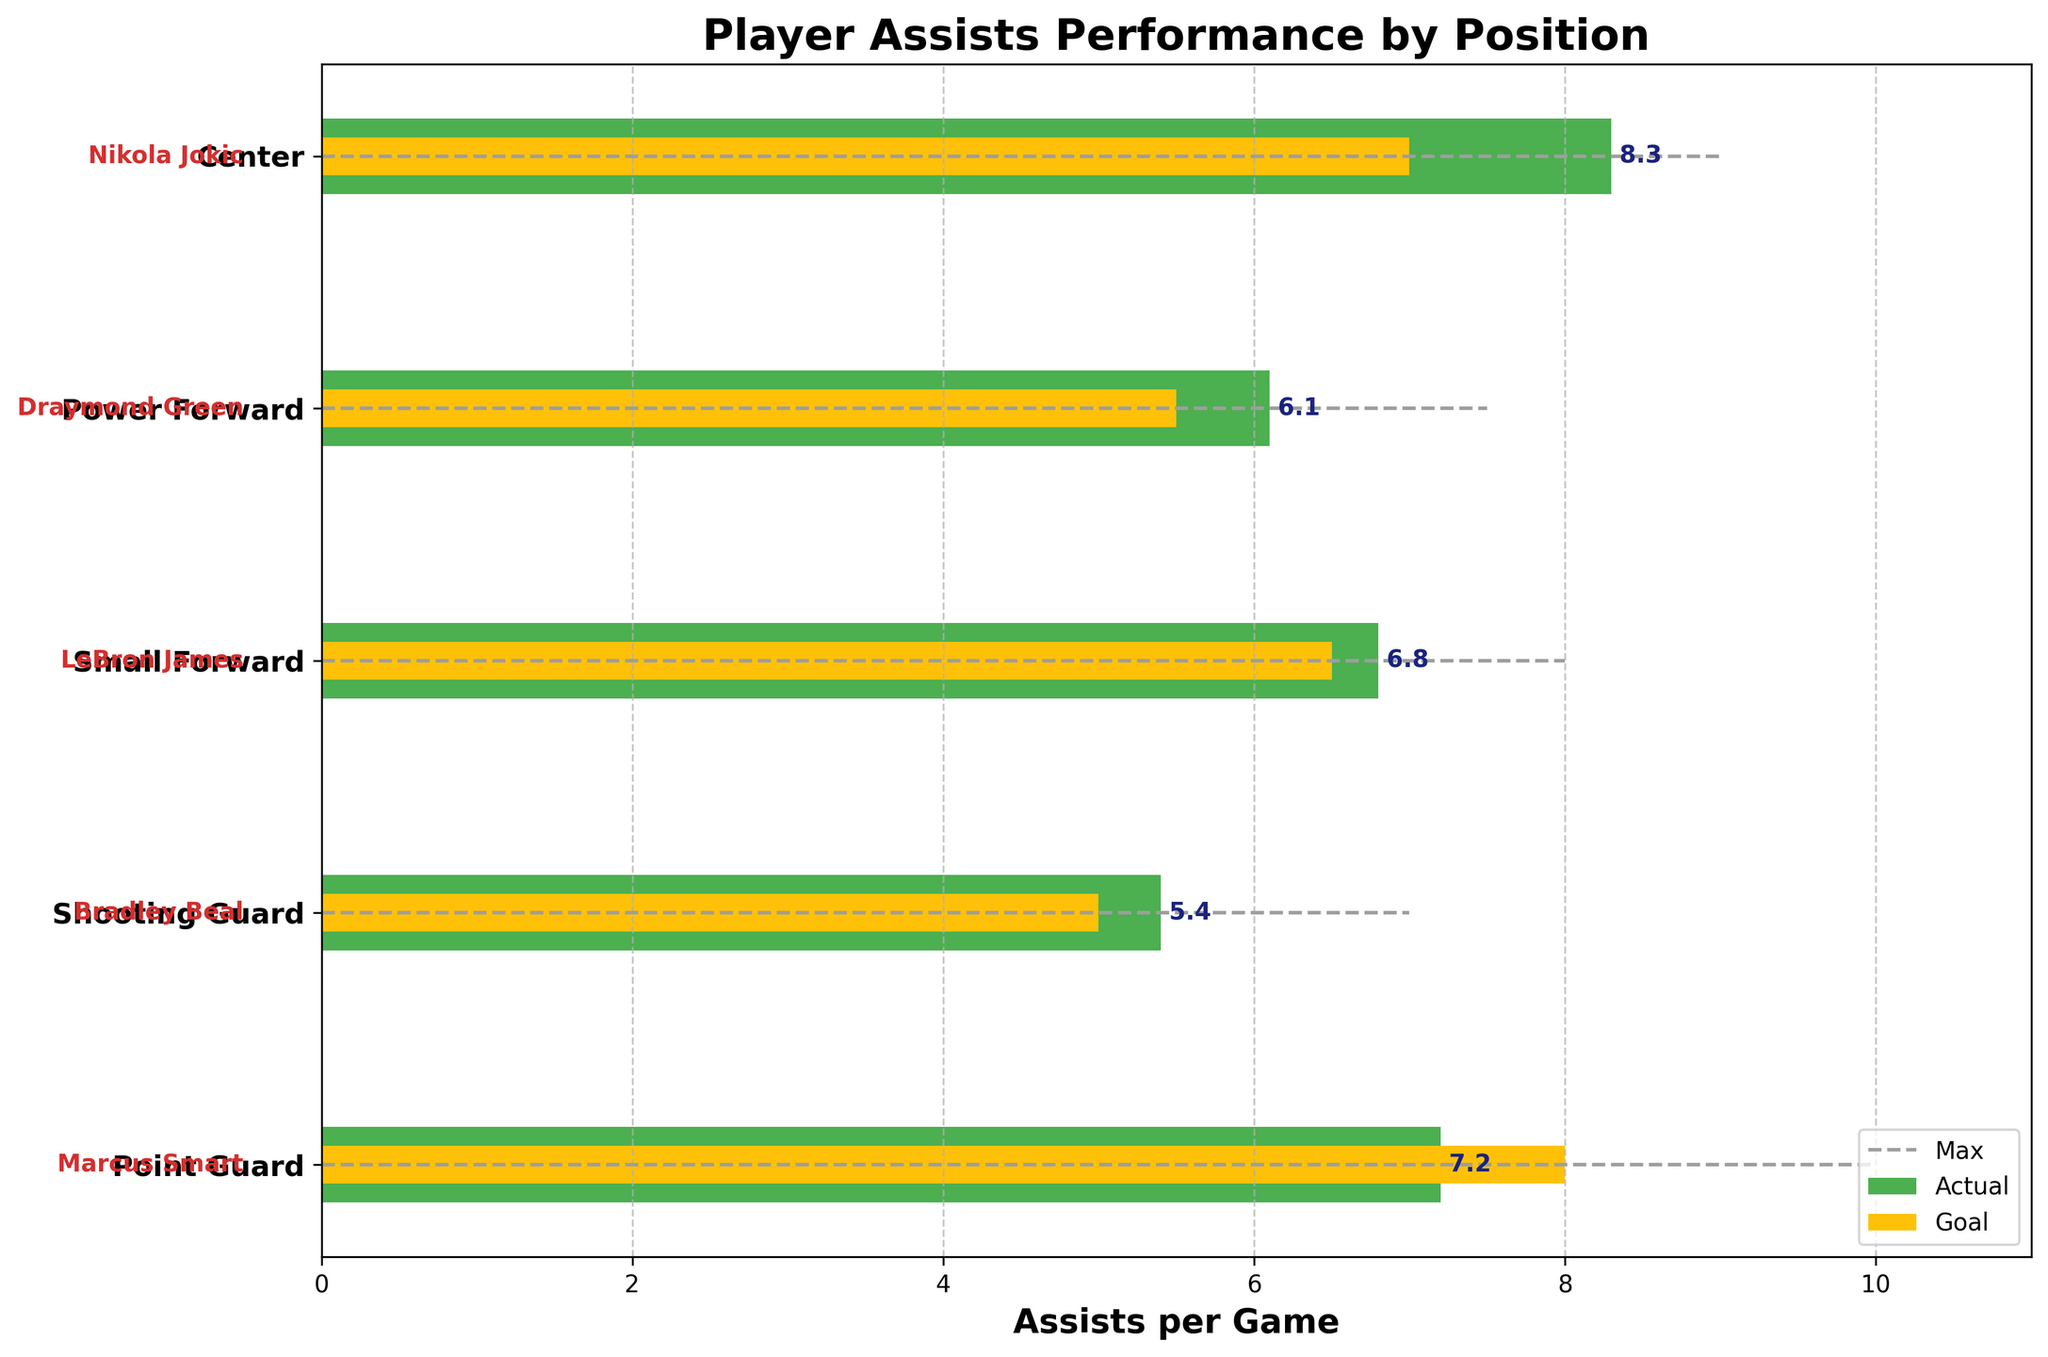what is the title of the figure? The title is typically displayed at the top of the chart in a bolder and larger font size. By looking at this part of the plot, you can find the title of the figure.
Answer: Player Assists Performance by Position what position does LeBron James play? Player names are shown to the left side of the chart, beside each bar. By locating the name "LeBron James," you can see the corresponding position.
Answer: Small Forward which player has the highest actual assists per game? Check all the bars' lengths on the horizontal axis. The longest bar represents the highest actual assists per game.
Answer: Nikola Jokic how many players exceed their goal in assists per game? Look at each bar to see if the green bar (actual) extends beyond the smaller yellow bar (goal). Count the players who have this feature.
Answer: 3 do all Point Guards meet their goal? Locate the Point Guard's data and compare the green bar (actual) to the yellow bar (goal). If the green bar doesn't reach or surpass the yellow bar, they did not meet their goal.
Answer: No who has the smallest difference between actual and goal assists per game? Calculate the difference for each player by subtracting the goal value from the actual value. Determine the player with the smallest difference.
Answer: Bradley Beal which position has the highest goal for assists per game? Look at the yellow bars representing the goal values for each position. Identify the yellow bar that extends farthest along the horizontal axis.
Answer: Point Guard by how much does Marcus Smart's actual assists per game fall short of his goal? Since Marcus Smart plays Point Guard, subtract his actual assist value from his goal assist value. Calculation: 8.0 (goal) - 7.2 (actual) = 0.8.
Answer: 0.8 does any player's actual assists exceed the max value? Compare everyone's actual assist bar (green) with the thin dashed line that indicates the max value. Check if any green bars surpass the dashed lines.
Answer: No between Draymond Green and LeBron James, who has a higher actual assists per game? Locate the bars for both players and compare their lengths to determine whose green bar extends further.
Answer: LeBron James 